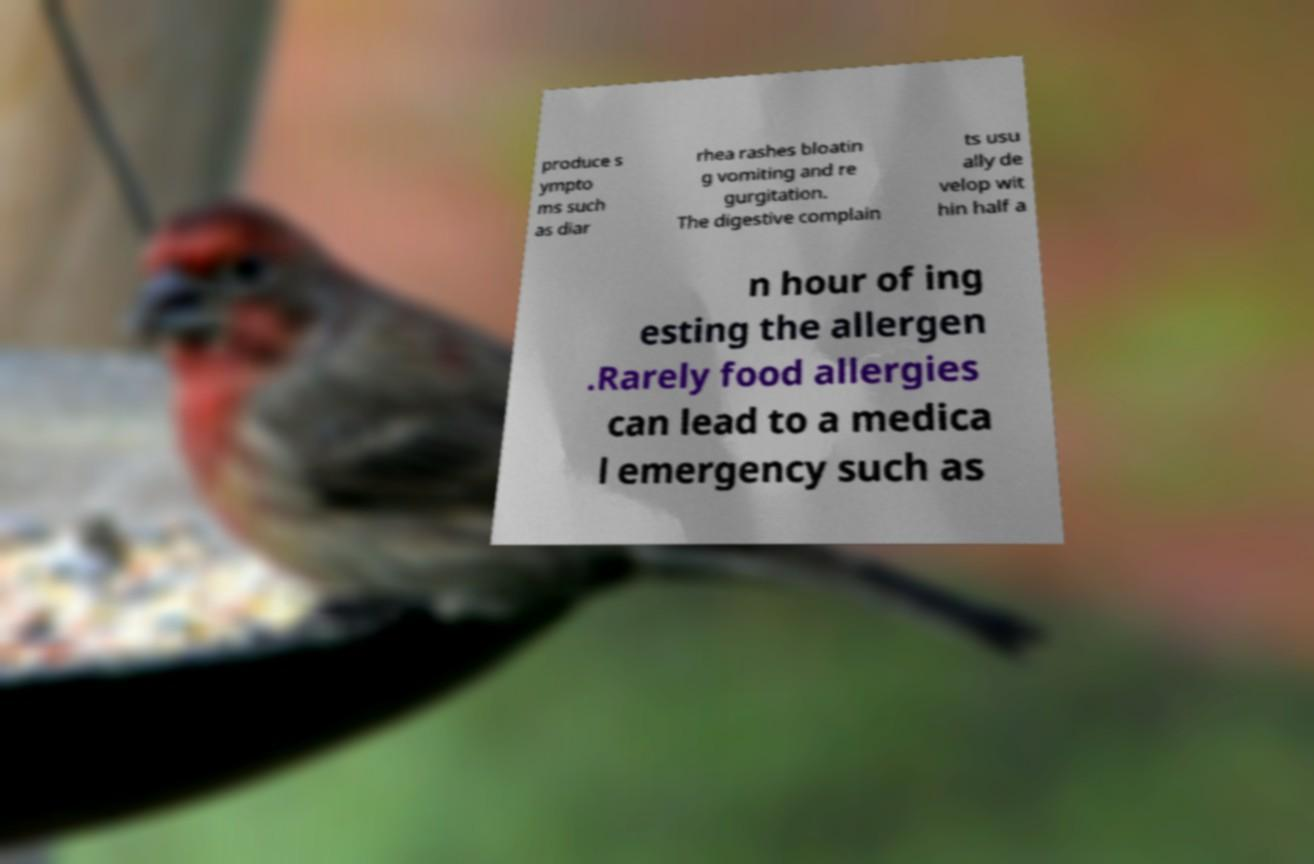Can you read and provide the text displayed in the image?This photo seems to have some interesting text. Can you extract and type it out for me? produce s ympto ms such as diar rhea rashes bloatin g vomiting and re gurgitation. The digestive complain ts usu ally de velop wit hin half a n hour of ing esting the allergen .Rarely food allergies can lead to a medica l emergency such as 